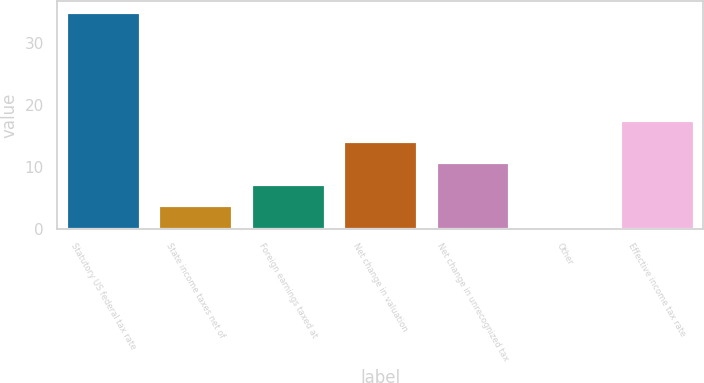Convert chart. <chart><loc_0><loc_0><loc_500><loc_500><bar_chart><fcel>Statutory US federal tax rate<fcel>State income taxes net of<fcel>Foreign earnings taxed at<fcel>Net change in valuation<fcel>Net change in unrecognized tax<fcel>Other<fcel>Effective income tax rate<nl><fcel>35<fcel>3.77<fcel>7.24<fcel>14.18<fcel>10.71<fcel>0.3<fcel>17.65<nl></chart> 